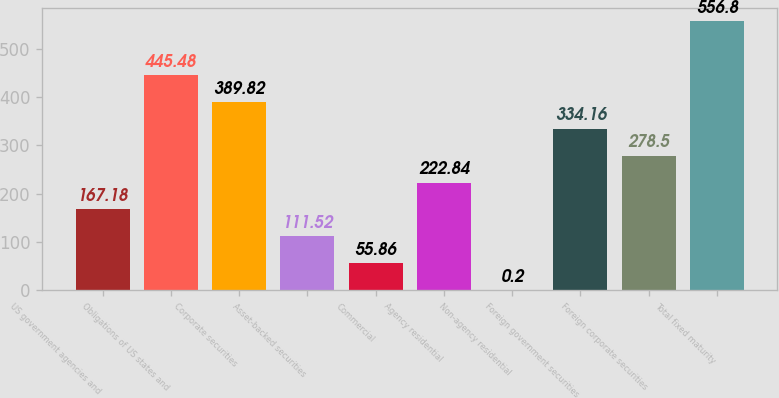Convert chart. <chart><loc_0><loc_0><loc_500><loc_500><bar_chart><fcel>US government agencies and<fcel>Obligations of US states and<fcel>Corporate securities<fcel>Asset-backed securities<fcel>Commercial<fcel>Agency residential<fcel>Non-agency residential<fcel>Foreign government securities<fcel>Foreign corporate securities<fcel>Total fixed maturity<nl><fcel>167.18<fcel>445.48<fcel>389.82<fcel>111.52<fcel>55.86<fcel>222.84<fcel>0.2<fcel>334.16<fcel>278.5<fcel>556.8<nl></chart> 